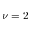Convert formula to latex. <formula><loc_0><loc_0><loc_500><loc_500>\nu = 2</formula> 